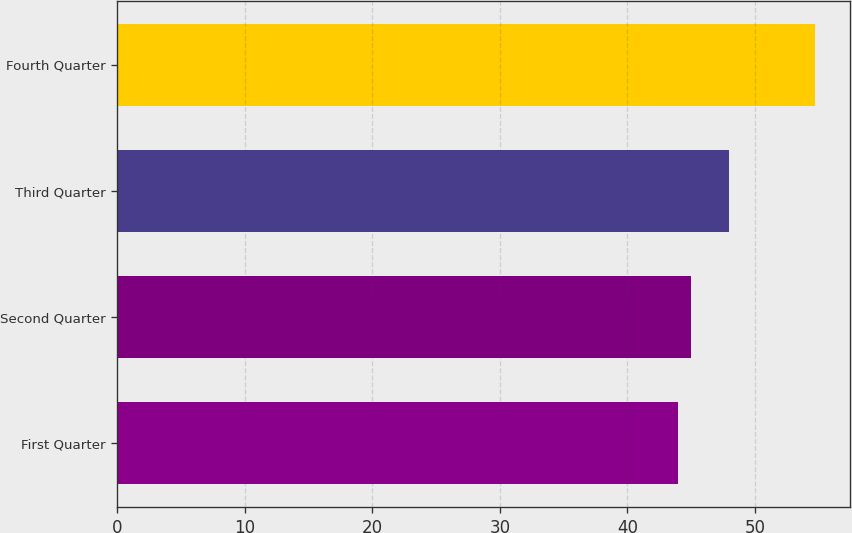Convert chart. <chart><loc_0><loc_0><loc_500><loc_500><bar_chart><fcel>First Quarter<fcel>Second Quarter<fcel>Third Quarter<fcel>Fourth Quarter<nl><fcel>43.94<fcel>45.02<fcel>47.96<fcel>54.75<nl></chart> 